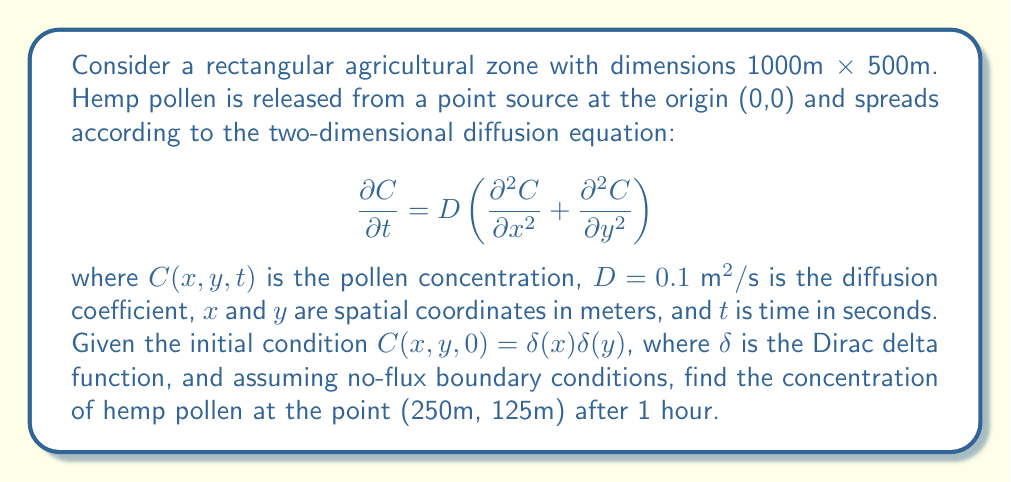Help me with this question. To solve this problem, we need to use the solution to the two-dimensional diffusion equation with a point source initial condition. The solution is given by:

$$C(x,y,t) = \frac{M}{4\pi Dt} \exp\left(-\frac{x^2+y^2}{4Dt}\right)$$

where $M$ is the total mass of pollen released.

Steps to solve:

1) First, we need to determine $M$. Since the initial condition is a Dirac delta function, the total mass is 1 unit.

2) We're asked to find the concentration after 1 hour, so $t = 3600$ seconds.

3) The point of interest is (250m, 125m).

4) The diffusion coefficient $D = 0.1 \text{ m}^2/\text{s}$.

5) Substituting these values into the equation:

   $$C(250,125,3600) = \frac{1}{4\pi(0.1)(3600)} \exp\left(-\frac{250^2+125^2}{4(0.1)(3600)}\right)$$

6) Simplify:
   $$C(250,125,3600) = \frac{1}{1440\pi} \exp\left(-\frac{78125}{1440}\right)$$

7) Calculate the result:
   $$C(250,125,3600) \approx 1.0242 \times 10^{-7} \text{ units/m}^2$$

Note: The concentration is very low because hemp pollen is relatively heavy and doesn't travel far from its source. In reality, wind and other factors would significantly affect the dispersion, which this simple model doesn't account for.
Answer: The concentration of hemp pollen at the point (250m, 125m) after 1 hour is approximately $1.0242 \times 10^{-7} \text{ units/m}^2$. 